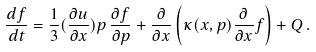Convert formula to latex. <formula><loc_0><loc_0><loc_500><loc_500>\frac { d f } { d t } = \frac { 1 } { 3 } ( \frac { \partial u } { \partial x } ) p \, \frac { \partial f } { \partial p } + \frac { \partial } { \partial x } \left ( \kappa ( x , p ) \frac { \partial } { \partial x } f \right ) + Q \, .</formula> 